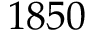<formula> <loc_0><loc_0><loc_500><loc_500>1 8 5 0</formula> 